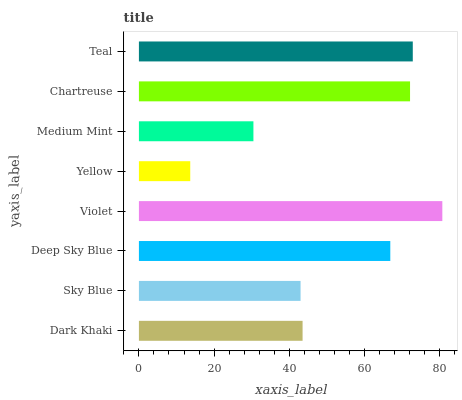Is Yellow the minimum?
Answer yes or no. Yes. Is Violet the maximum?
Answer yes or no. Yes. Is Sky Blue the minimum?
Answer yes or no. No. Is Sky Blue the maximum?
Answer yes or no. No. Is Dark Khaki greater than Sky Blue?
Answer yes or no. Yes. Is Sky Blue less than Dark Khaki?
Answer yes or no. Yes. Is Sky Blue greater than Dark Khaki?
Answer yes or no. No. Is Dark Khaki less than Sky Blue?
Answer yes or no. No. Is Deep Sky Blue the high median?
Answer yes or no. Yes. Is Dark Khaki the low median?
Answer yes or no. Yes. Is Teal the high median?
Answer yes or no. No. Is Violet the low median?
Answer yes or no. No. 